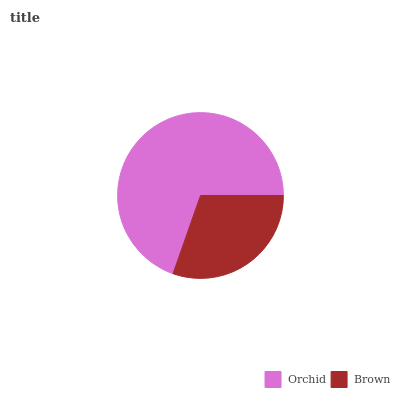Is Brown the minimum?
Answer yes or no. Yes. Is Orchid the maximum?
Answer yes or no. Yes. Is Brown the maximum?
Answer yes or no. No. Is Orchid greater than Brown?
Answer yes or no. Yes. Is Brown less than Orchid?
Answer yes or no. Yes. Is Brown greater than Orchid?
Answer yes or no. No. Is Orchid less than Brown?
Answer yes or no. No. Is Orchid the high median?
Answer yes or no. Yes. Is Brown the low median?
Answer yes or no. Yes. Is Brown the high median?
Answer yes or no. No. Is Orchid the low median?
Answer yes or no. No. 